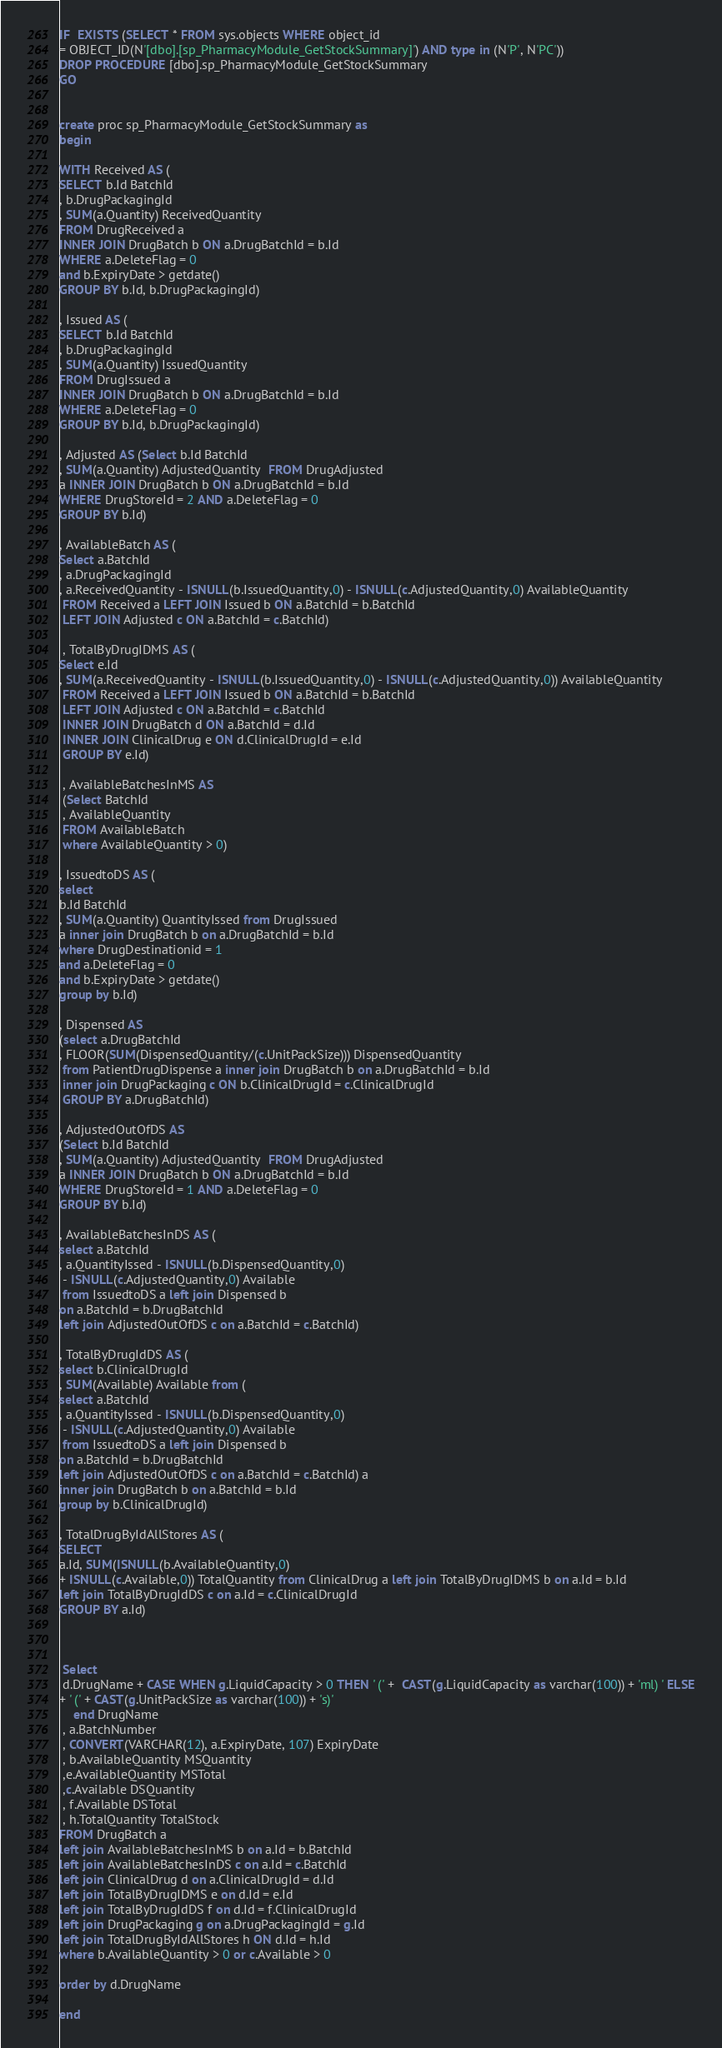<code> <loc_0><loc_0><loc_500><loc_500><_SQL_>IF  EXISTS (SELECT * FROM sys.objects WHERE object_id 
= OBJECT_ID(N'[dbo].[sp_PharmacyModule_GetStockSummary]') AND type in (N'P', N'PC'))
DROP PROCEDURE [dbo].sp_PharmacyModule_GetStockSummary
GO


create proc sp_PharmacyModule_GetStockSummary as
begin

WITH Received AS (
SELECT b.Id BatchId 
, b.DrugPackagingId
, SUM(a.Quantity) ReceivedQuantity
FROM DrugReceived a 
INNER JOIN DrugBatch b ON a.DrugBatchId = b.Id
WHERE a.DeleteFlag = 0
and b.ExpiryDate > getdate()
GROUP BY b.Id, b.DrugPackagingId)

, Issued AS (
SELECT b.Id BatchId 
, b.DrugPackagingId
, SUM(a.Quantity) IssuedQuantity
FROM DrugIssued a 
INNER JOIN DrugBatch b ON a.DrugBatchId = b.Id
WHERE a.DeleteFlag = 0
GROUP BY b.Id, b.DrugPackagingId)

, Adjusted AS (Select b.Id BatchId
, SUM(a.Quantity) AdjustedQuantity  FROM DrugAdjusted 
a INNER JOIN DrugBatch b ON a.DrugBatchId = b.Id
WHERE DrugStoreId = 2 AND a.DeleteFlag = 0
GROUP BY b.Id) 

, AvailableBatch AS (
Select a.BatchId
, a.DrugPackagingId
, a.ReceivedQuantity - ISNULL(b.IssuedQuantity,0) - ISNULL(c.AdjustedQuantity,0) AvailableQuantity
 FROM Received a LEFT JOIN Issued b ON a.BatchId = b.BatchId
 LEFT JOIN Adjusted c ON a.BatchId = c.BatchId)

 , TotalByDrugIDMS AS (
Select e.Id
, SUM(a.ReceivedQuantity - ISNULL(b.IssuedQuantity,0) - ISNULL(c.AdjustedQuantity,0)) AvailableQuantity
 FROM Received a LEFT JOIN Issued b ON a.BatchId = b.BatchId
 LEFT JOIN Adjusted c ON a.BatchId = c.BatchId
 INNER JOIN DrugBatch d ON a.BatchId = d.Id
 INNER JOIN ClinicalDrug e ON d.ClinicalDrugId = e.Id
 GROUP BY e.Id)

 , AvailableBatchesInMS AS
 (Select BatchId
 , AvailableQuantity
 FROM AvailableBatch 
 where AvailableQuantity > 0)

, IssuedtoDS AS (
select 
b.Id BatchId
, SUM(a.Quantity) QuantityIssed from DrugIssued
a inner join DrugBatch b on a.DrugBatchId = b.Id
where DrugDestinationid = 1
and a.DeleteFlag = 0
and b.ExpiryDate > getdate()
group by b.Id)

, Dispensed AS 
(select a.DrugBatchId
, FLOOR(SUM(DispensedQuantity/(c.UnitPackSize))) DispensedQuantity
 from PatientDrugDispense a inner join DrugBatch b on a.DrugBatchId = b.Id
 inner join DrugPackaging c ON b.ClinicalDrugId = c.ClinicalDrugId
 GROUP BY a.DrugBatchId)

, AdjustedOutOfDS AS 
(Select b.Id BatchId
, SUM(a.Quantity) AdjustedQuantity  FROM DrugAdjusted 
a INNER JOIN DrugBatch b ON a.DrugBatchId = b.Id
WHERE DrugStoreId = 1 AND a.DeleteFlag = 0
GROUP BY b.Id) 

, AvailableBatchesInDS AS (
select a.BatchId
, a.QuantityIssed - ISNULL(b.DispensedQuantity,0)
 - ISNULL(c.AdjustedQuantity,0) Available
 from IssuedtoDS a left join Dispensed b
on a.BatchId = b.DrugBatchId
left join AdjustedOutOfDS c on a.BatchId = c.BatchId)

, TotalByDrugIdDS AS (
select b.ClinicalDrugId
, SUM(Available) Available from (
select a.BatchId
, a.QuantityIssed - ISNULL(b.DispensedQuantity,0)
 - ISNULL(c.AdjustedQuantity,0) Available
 from IssuedtoDS a left join Dispensed b
on a.BatchId = b.DrugBatchId
left join AdjustedOutOfDS c on a.BatchId = c.BatchId) a
inner join DrugBatch b on a.BatchId = b.Id
group by b.ClinicalDrugId) 

, TotalDrugByIdAllStores AS (
SELECT 
a.Id, SUM(ISNULL(b.AvailableQuantity,0) 
+ ISNULL(c.Available,0)) TotalQuantity from ClinicalDrug a left join TotalByDrugIDMS b on a.Id = b.Id
left join TotalByDrugIdDS c on a.Id = c.ClinicalDrugId
GROUP BY a.Id)



 Select 
 d.DrugName + CASE WHEN g.LiquidCapacity > 0 THEN ' (' +  CAST(g.LiquidCapacity as varchar(100)) + 'ml) ' ELSE
+ ' (' + CAST(g.UnitPackSize as varchar(100)) + 's)' 
	end DrugName
 , a.BatchNumber 
 , CONVERT(VARCHAR(12), a.ExpiryDate, 107) ExpiryDate
 , b.AvailableQuantity MSQuantity
 ,e.AvailableQuantity MSTotal
 ,c.Available DSQuantity
 , f.Available DSTotal
 , h.TotalQuantity TotalStock
FROM DrugBatch a
left join AvailableBatchesInMS b on a.Id = b.BatchId
left join AvailableBatchesInDS c on a.Id = c.BatchId
left join ClinicalDrug d on a.ClinicalDrugId = d.Id
left join TotalByDrugIDMS e on d.Id = e.Id
left join TotalByDrugIdDS f on d.Id = f.ClinicalDrugId
left join DrugPackaging g on a.DrugPackagingId = g.Id
left join TotalDrugByIdAllStores h ON d.Id = h.Id
where b.AvailableQuantity > 0 or c.Available > 0

order by d.DrugName

end</code> 